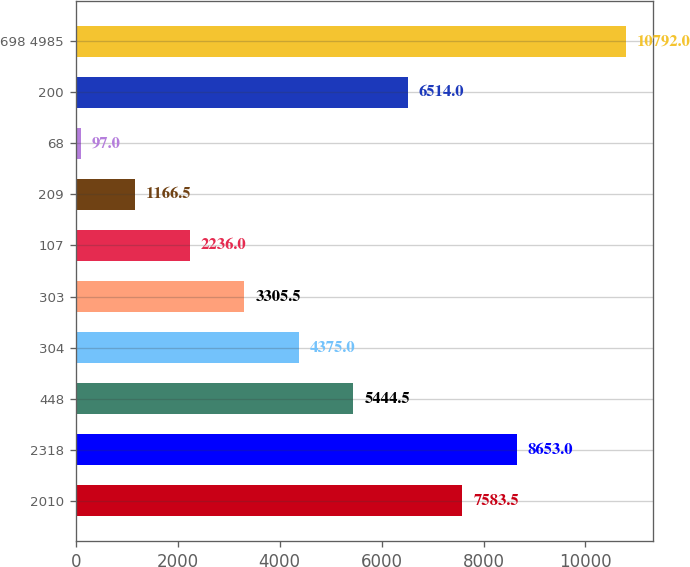Convert chart. <chart><loc_0><loc_0><loc_500><loc_500><bar_chart><fcel>2010<fcel>2318<fcel>448<fcel>304<fcel>303<fcel>107<fcel>209<fcel>68<fcel>200<fcel>698 4985<nl><fcel>7583.5<fcel>8653<fcel>5444.5<fcel>4375<fcel>3305.5<fcel>2236<fcel>1166.5<fcel>97<fcel>6514<fcel>10792<nl></chart> 